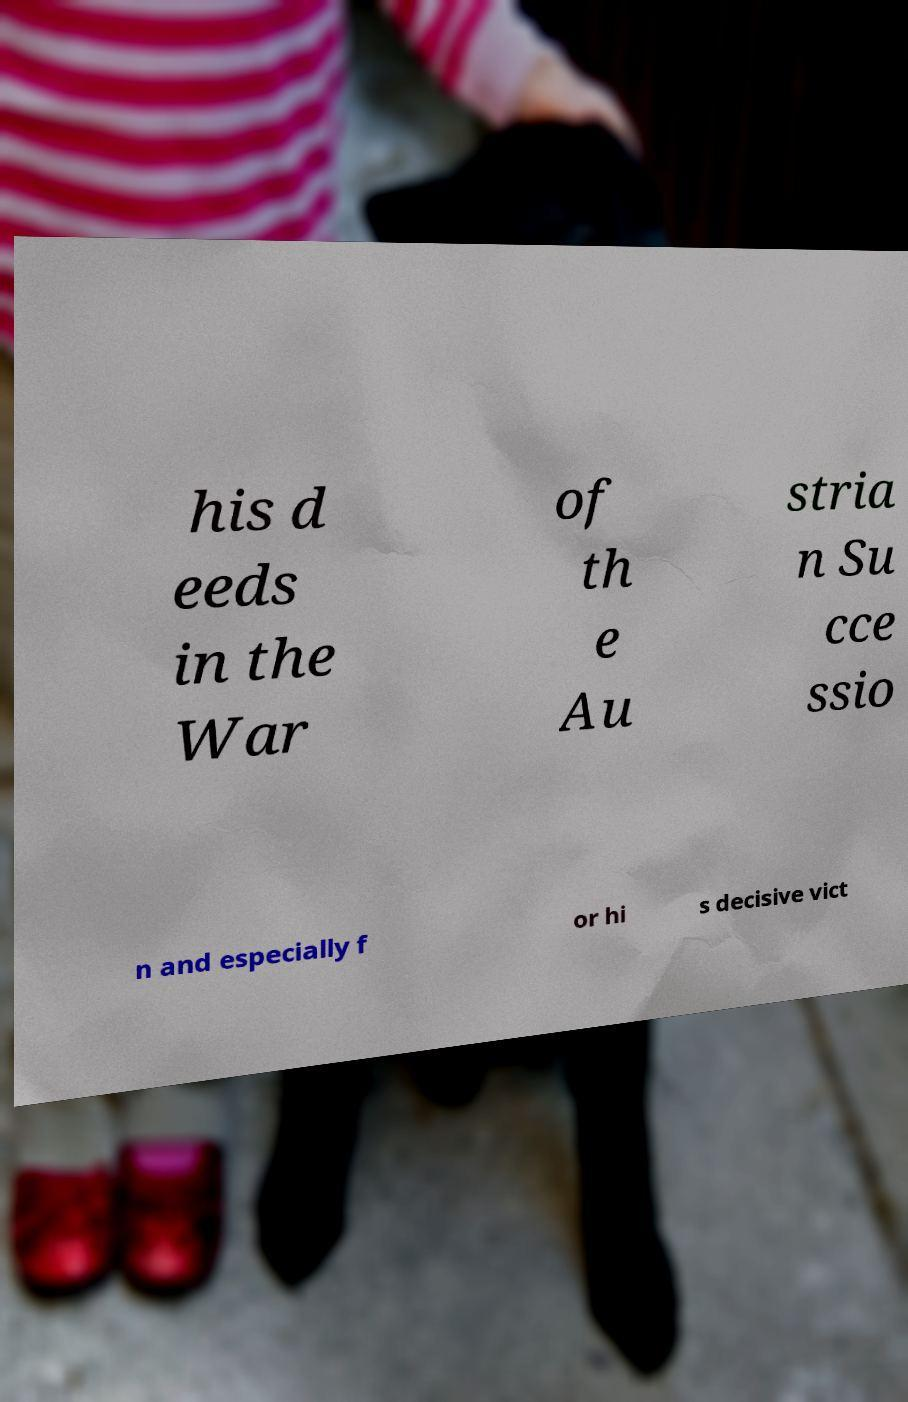What messages or text are displayed in this image? I need them in a readable, typed format. his d eeds in the War of th e Au stria n Su cce ssio n and especially f or hi s decisive vict 